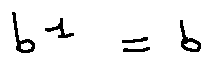Convert formula to latex. <formula><loc_0><loc_0><loc_500><loc_500>b ^ { 1 } = b</formula> 